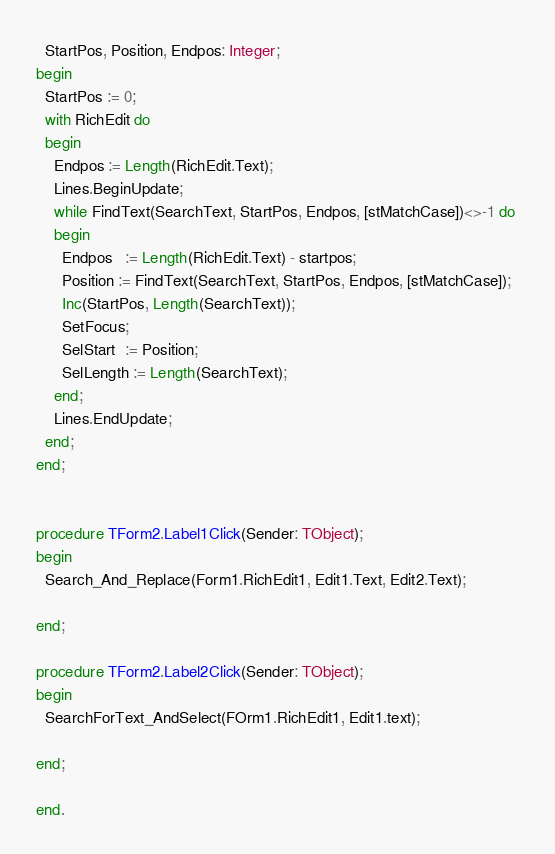<code> <loc_0><loc_0><loc_500><loc_500><_Pascal_>  StartPos, Position, Endpos: Integer; 
begin 
  StartPos := 0; 
  with RichEdit do 
  begin 
    Endpos := Length(RichEdit.Text); 
    Lines.BeginUpdate; 
    while FindText(SearchText, StartPos, Endpos, [stMatchCase])<>-1 do 
    begin 
      Endpos   := Length(RichEdit.Text) - startpos; 
      Position := FindText(SearchText, StartPos, Endpos, [stMatchCase]); 
      Inc(StartPos, Length(SearchText)); 
      SetFocus; 
      SelStart  := Position; 
      SelLength := Length(SearchText); 
    end; 
    Lines.EndUpdate; 
  end; 
end;


procedure TForm2.Label1Click(Sender: TObject);
begin
  Search_And_Replace(Form1.RichEdit1, Edit1.Text, Edit2.Text);

end;

procedure TForm2.Label2Click(Sender: TObject);
begin
  SearchForText_AndSelect(FOrm1.RichEdit1, Edit1.text);

end;

end.
</code> 